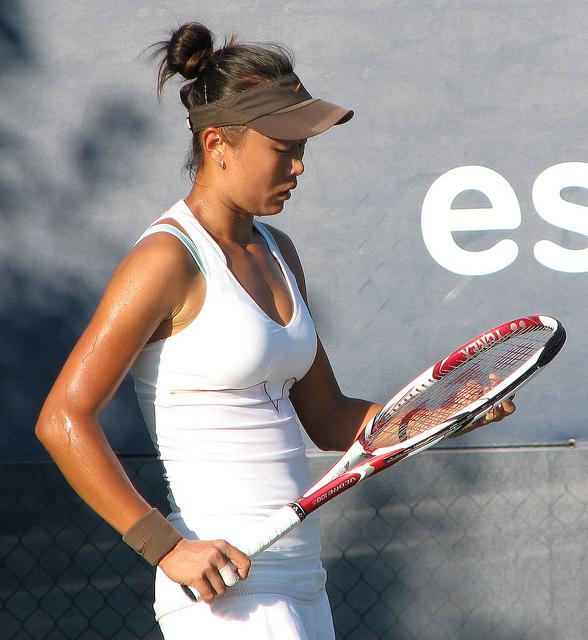Is her racket broken?
Keep it brief. No. How tired is she?
Give a very brief answer. Very. What style is the girls hair?
Write a very short answer. Ponytail. 